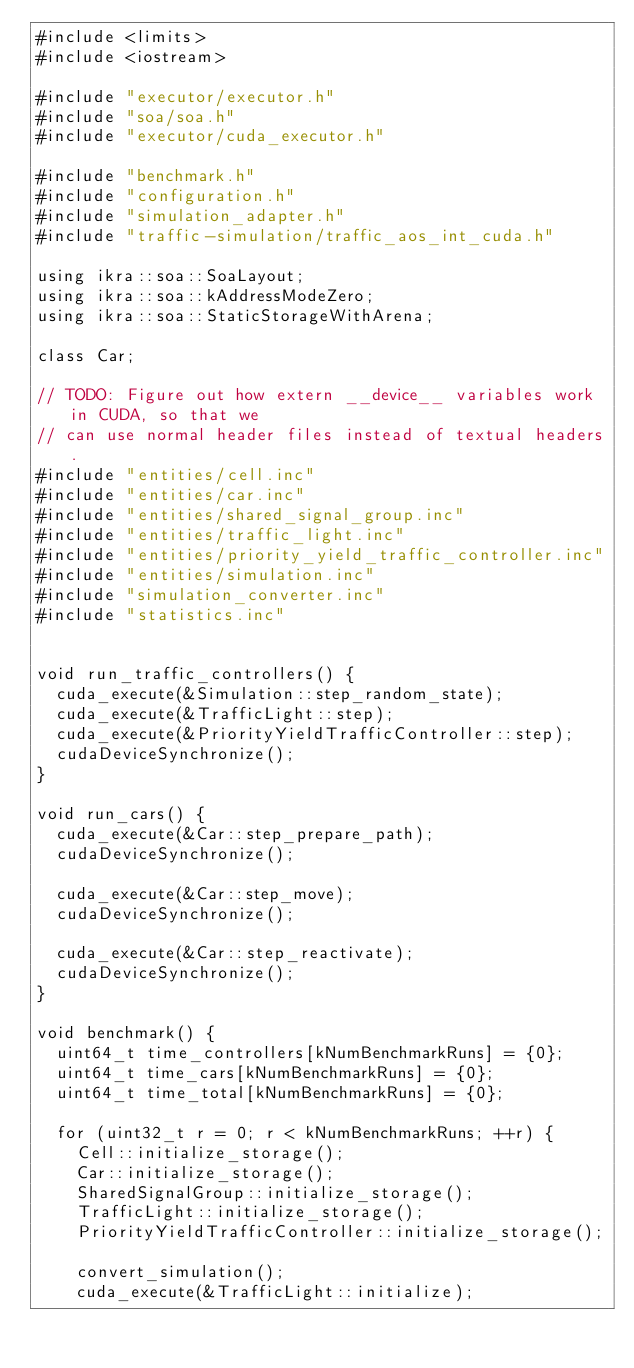Convert code to text. <code><loc_0><loc_0><loc_500><loc_500><_Cuda_>#include <limits>
#include <iostream>

#include "executor/executor.h"
#include "soa/soa.h"
#include "executor/cuda_executor.h"

#include "benchmark.h"
#include "configuration.h"
#include "simulation_adapter.h"
#include "traffic-simulation/traffic_aos_int_cuda.h"

using ikra::soa::SoaLayout;
using ikra::soa::kAddressModeZero;
using ikra::soa::StaticStorageWithArena;

class Car;

// TODO: Figure out how extern __device__ variables work in CUDA, so that we
// can use normal header files instead of textual headers.
#include "entities/cell.inc"
#include "entities/car.inc"
#include "entities/shared_signal_group.inc"
#include "entities/traffic_light.inc"
#include "entities/priority_yield_traffic_controller.inc"
#include "entities/simulation.inc"
#include "simulation_converter.inc"
#include "statistics.inc"


void run_traffic_controllers() {
  cuda_execute(&Simulation::step_random_state);
  cuda_execute(&TrafficLight::step);
  cuda_execute(&PriorityYieldTrafficController::step);
  cudaDeviceSynchronize();
}

void run_cars() {
  cuda_execute(&Car::step_prepare_path);
  cudaDeviceSynchronize();

  cuda_execute(&Car::step_move);
  cudaDeviceSynchronize();

  cuda_execute(&Car::step_reactivate);
  cudaDeviceSynchronize();
}

void benchmark() {
  uint64_t time_controllers[kNumBenchmarkRuns] = {0};
  uint64_t time_cars[kNumBenchmarkRuns] = {0};
  uint64_t time_total[kNumBenchmarkRuns] = {0};

  for (uint32_t r = 0; r < kNumBenchmarkRuns; ++r) {
    Cell::initialize_storage();
    Car::initialize_storage();
    SharedSignalGroup::initialize_storage();
    TrafficLight::initialize_storage();
    PriorityYieldTrafficController::initialize_storage();

    convert_simulation();
    cuda_execute(&TrafficLight::initialize);</code> 